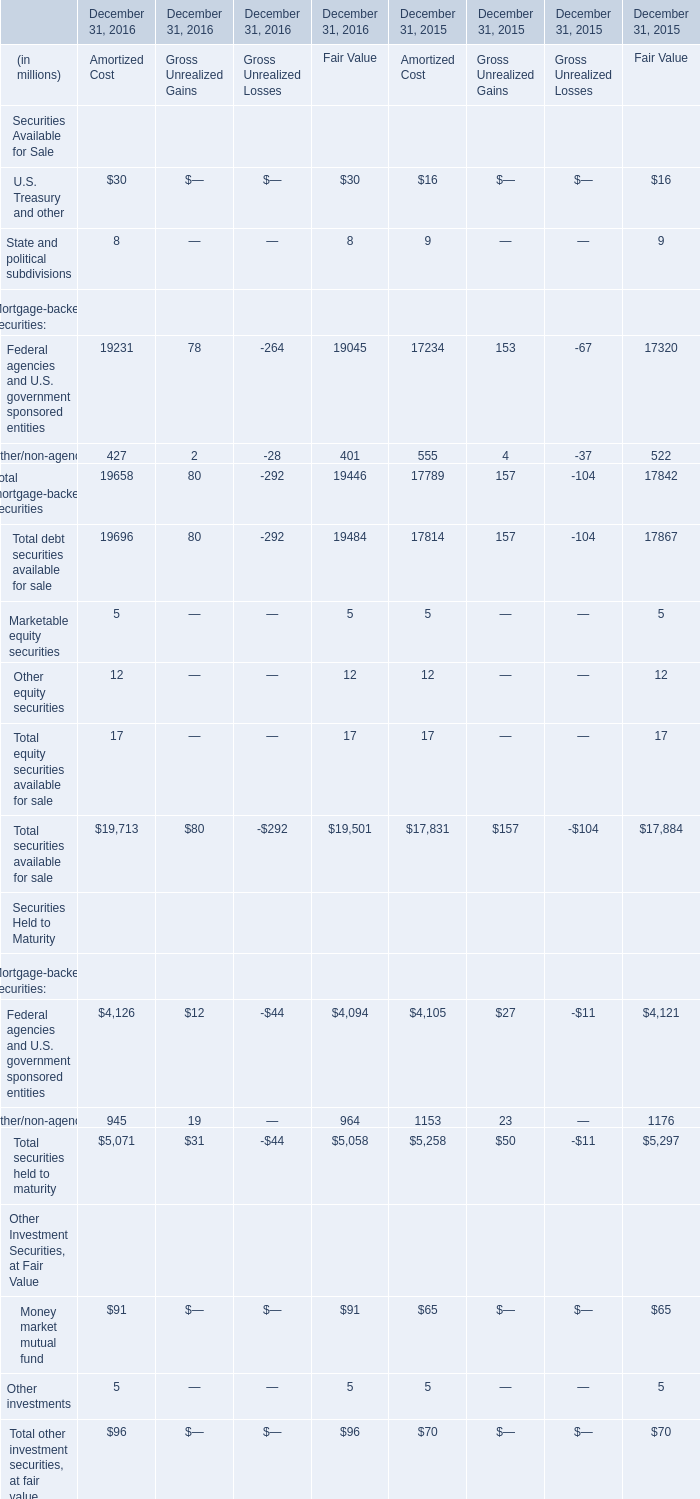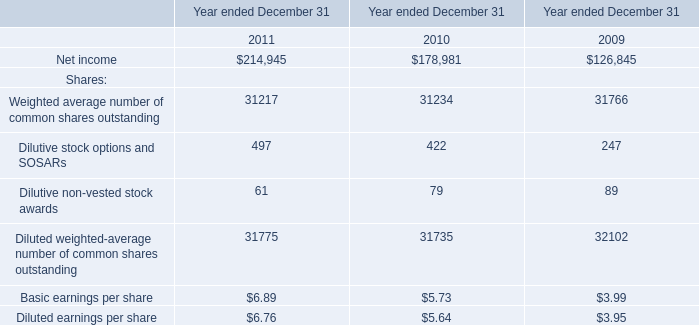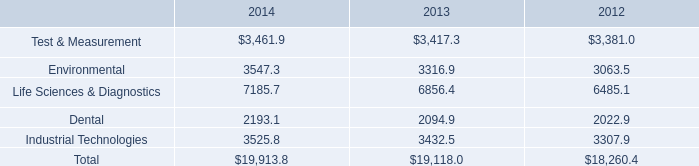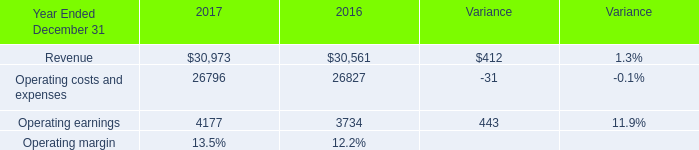How much of Securities Available for Sale is there in total in 2016 without Gross Unrealized Gains and Gross Unrealized Losses? (in million) 
Computations: (((30 + 8) + 30) + 8)
Answer: 76.0. 